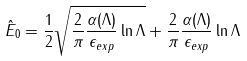<formula> <loc_0><loc_0><loc_500><loc_500>\hat { E } _ { 0 } = \frac { 1 } { 2 } \sqrt { \frac { 2 } { \pi } \frac { \alpha ( \Lambda ) } { \epsilon _ { e x p } } \ln \Lambda } + \frac { 2 } { \pi } \frac { \alpha ( \Lambda ) } { \epsilon _ { e x p } } \ln \Lambda</formula> 